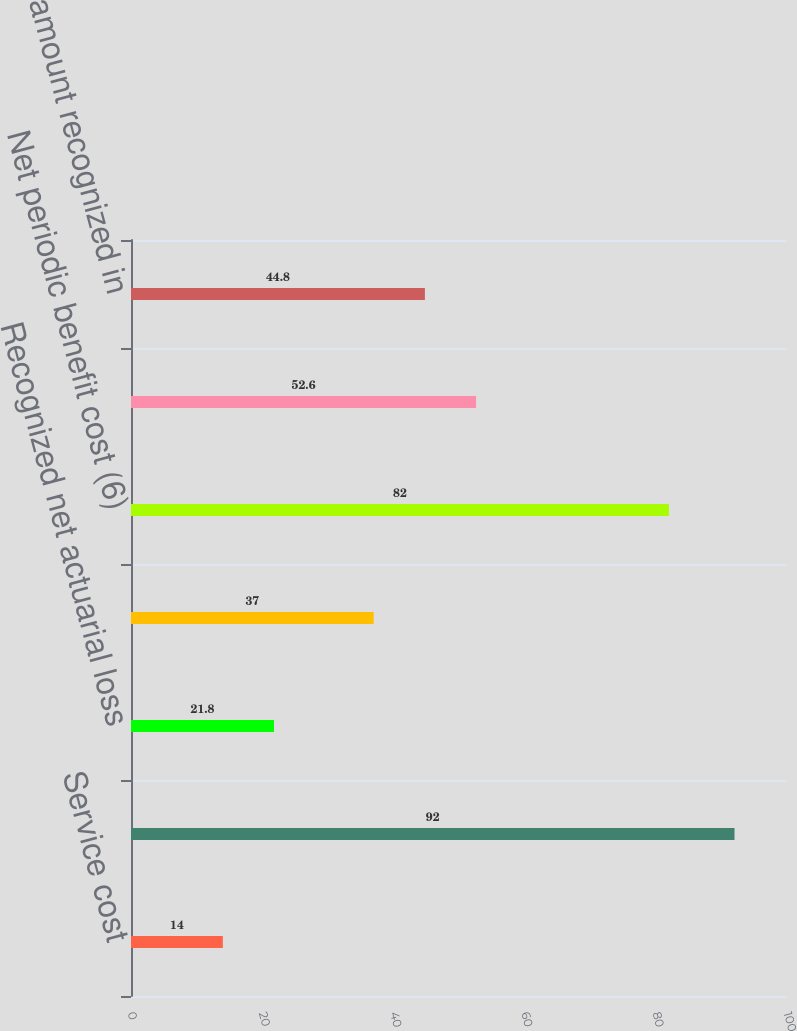<chart> <loc_0><loc_0><loc_500><loc_500><bar_chart><fcel>Service cost<fcel>Interest cost<fcel>Recognized net actuarial loss<fcel>Amortization of prior service<fcel>Net periodic benefit cost (6)<fcel>Discontinued operations<fcel>Net amount recognized in<nl><fcel>14<fcel>92<fcel>21.8<fcel>37<fcel>82<fcel>52.6<fcel>44.8<nl></chart> 